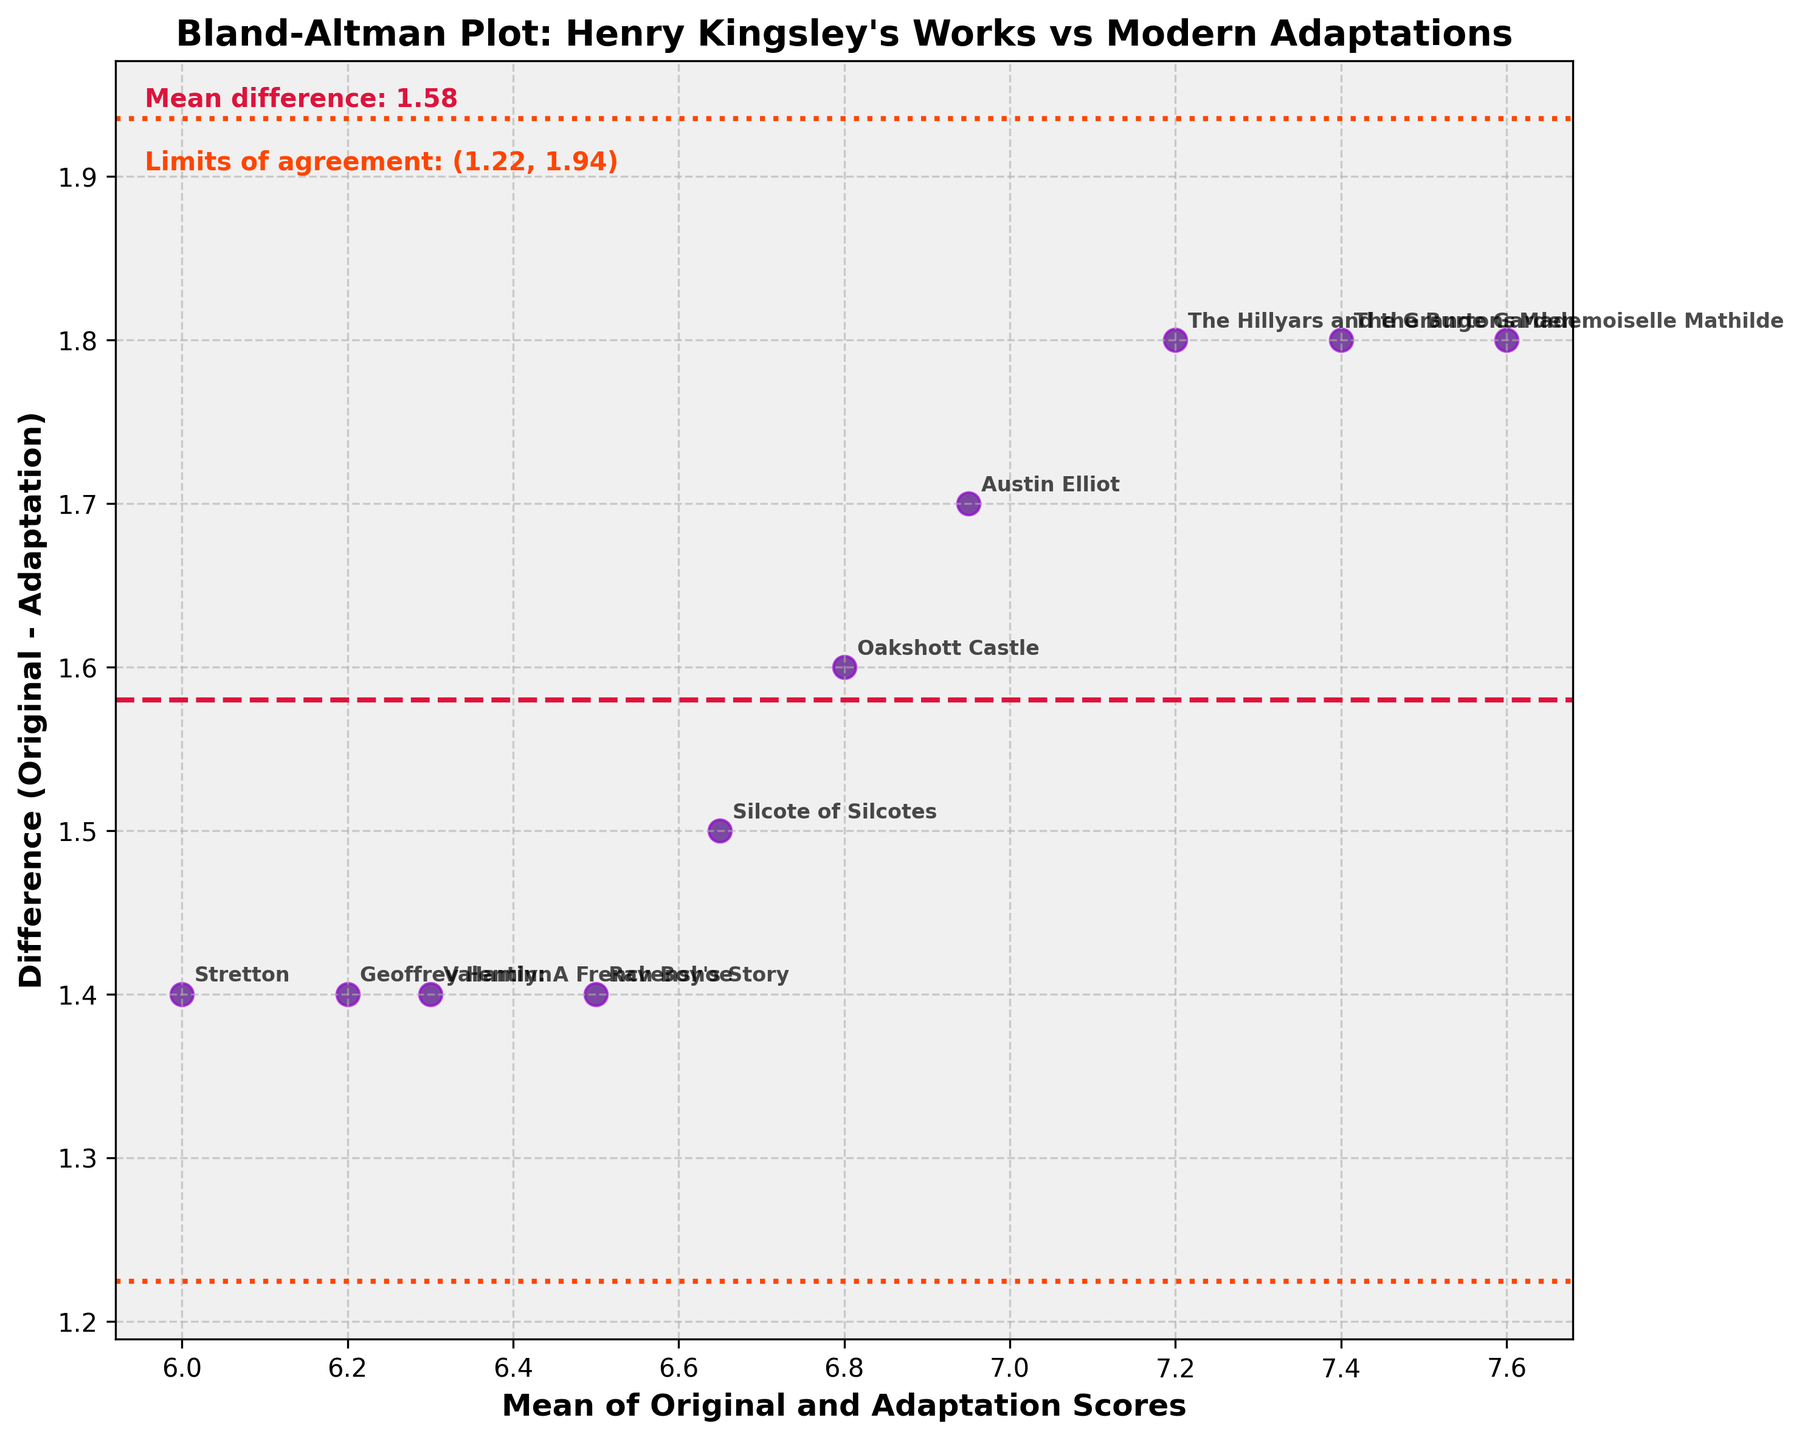What is the title of the figure? The title is displayed prominently at the top of the figure. It reads "Bland-Altman Plot: Henry Kingsley's Works vs Modern Adaptations."
Answer: Bland-Altman Plot: Henry Kingsley's Works vs Modern Adaptations What is the color of the main scatter points? The scatter points are plotted with a hue, leaning towards a dark purple or indigo color, making them stand out against the lighter background.
Answer: Indigo What is the mean difference between the original and adaptation scores? The mean difference is given in the annotation on the figure. It states "Mean difference: 1.74."
Answer: 1.74 What are the limits of agreement? The text annotation on the figure specifies the limits of agreement. It reads "Limits of agreement: (1.17, 2.31)."
Answer: (1.17, 2.31) Which work has the largest mean score, and what are the respective values for the original and adaptation scores? By comparing the means, "Mademoiselle Mathilde" shows the largest mean score. The original score is 8.5, and the adaptation score is 6.7.
Answer: Mademoiselle Mathilde; 8.5, 6.7 Which data point shows the smallest difference between the original and adaptation scores? The point closest to zero on the y-axis indicates the smallest difference. "Geoffrey Hamlyn" seems to be very close to zero with a difference approaching (6.9 - 5.5).
Answer: Geoffrey Hamlyn How many data points are there in the plot? Each work title corresponds to a data point in the plot. Counting the annotations or points shows there are 10 data points.
Answer: 10 What is the average of the means of original and adaptation scores for "Ravenshoe" and "Silcote of Silcotes"? First, calculate the means for both works: (7.2 + 5.8) / 2 = 6.5 for "Ravenshoe," and (7.4 + 5.9) / 2 = 6.65 for "Silcote of Silcotes." The average is (6.5 + 6.65) / 2 = 6.575.
Answer: 6.575 Is there any work with a difference above the upper limit of agreement? Observing the plot, none of the points exceed the upper limit of agreement line at 2.31. Hence, there is no work with such a difference.
Answer: No Which work has the largest difference between the original and adaptation scores? The work with the largest difference will have the highest value on the vertical (difference) axis. "Mademoiselle Mathilde" stands out with a significant difference around (8.5 - 6.7).
Answer: Mademoiselle Mathilde 